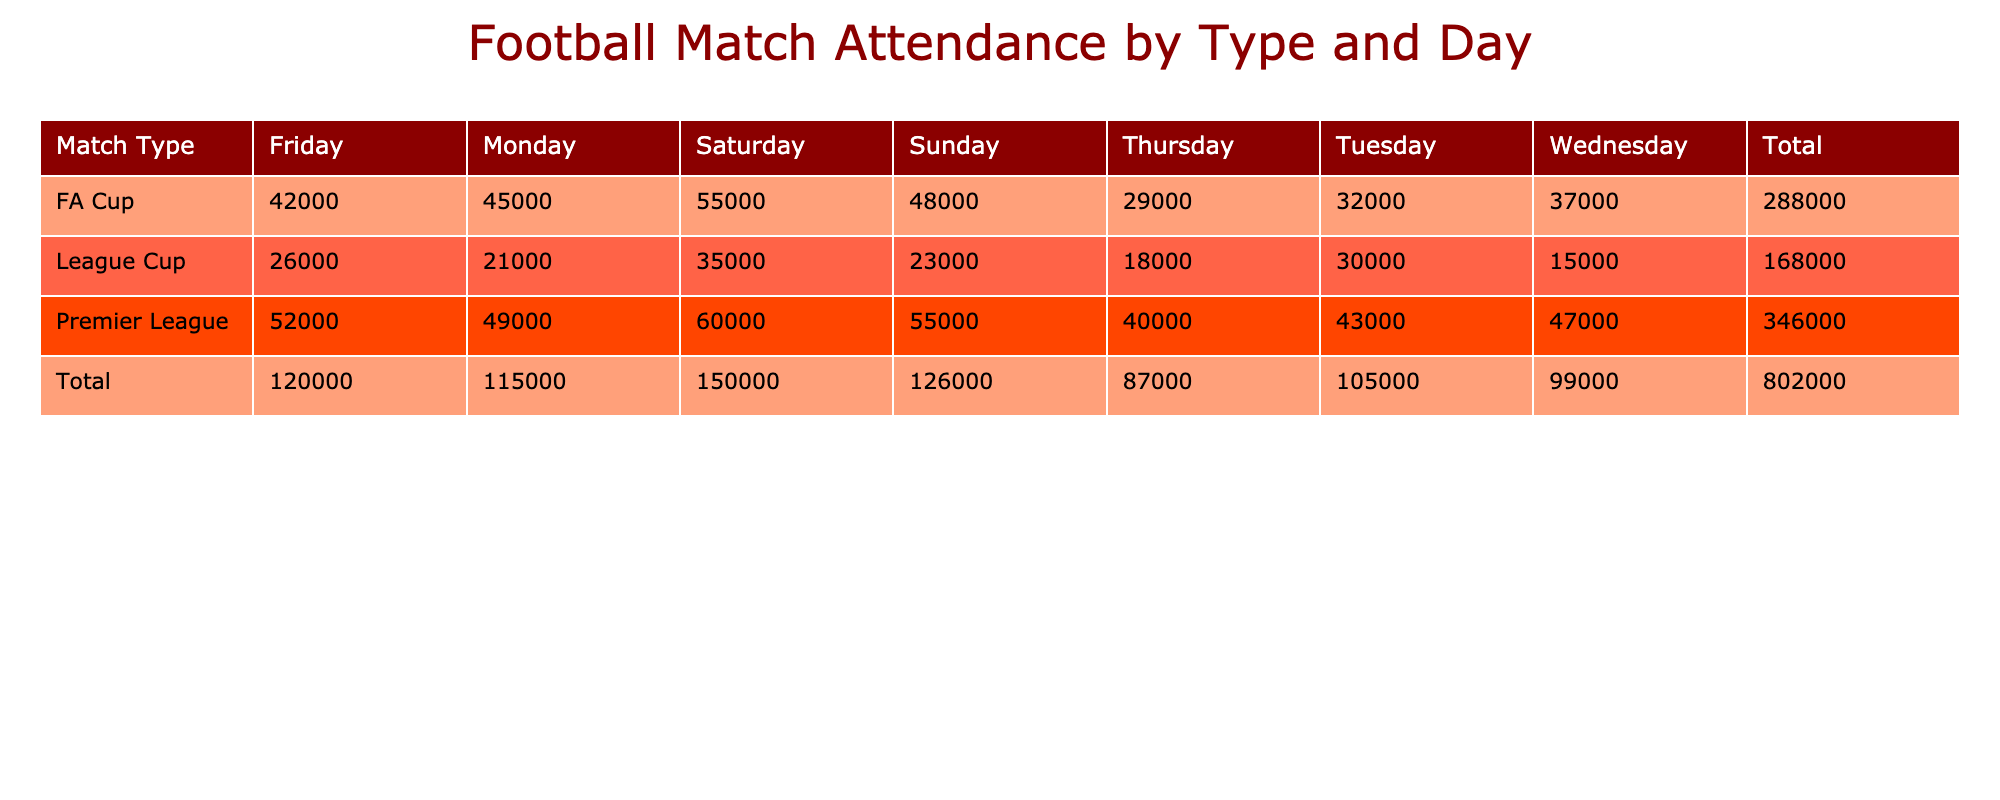What is the highest attendance for FA Cup matches? By looking at the FA Cup row, the highest value is listed under Saturday with an attendance of 55000.
Answer: 55000 Which day had the least attendance for the League Cup? In the League Cup row, Wednesday has the lowest attendance figure at 15000.
Answer: 15000 True or False: The Premier League had a higher attendance on Mondays compared to the League Cup. The Premier League attendance on Monday is 49000, while the League Cup has 21000. Hence, Premier League attendance is indeed higher.
Answer: True What is the total attendance for all League Cup matches? The total for League Cup is calculated by adding all attendances: 21000 + 30000 + 15000 + 18000 + 26000 + 35000 + 23000 = 168000.
Answer: 168000 On which day does the Premier League have the highest attendance, and what is that figure? The highest attendance for Premier League matches is on Saturday, with a count of 60000.
Answer: 60000 Calculate the average attendance for FA Cup matches. The FA Cup attendance figures are: 45000, 32000, 37000, 29000, 42000, 55000, and 48000. There are 7 values to average, so sum them up (45000 + 32000 + 37000 + 29000 + 42000 + 55000 + 48000 = 288000) and divide by 7 to get 288000 / 7 = 41142.857, rounded down gives 41143.
Answer: 41143 Is the average attendance for the League Cup more than 25000? The total attendance for League Cup is 168000, and there are 7 matches, resulting in an average of 168000 / 7 = 24000, which is less than 25000.
Answer: False 